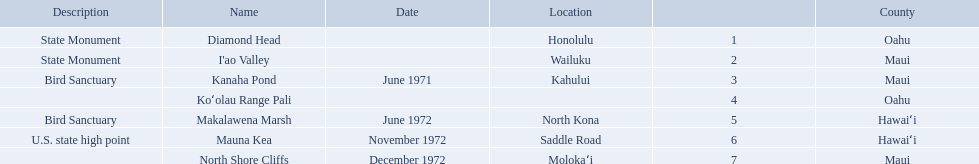What are the different landmark names? Diamond Head, I'ao Valley, Kanaha Pond, Koʻolau Range Pali, Makalawena Marsh, Mauna Kea, North Shore Cliffs. Which of these is located in the county hawai`i? Makalawena Marsh, Mauna Kea. Which of these is not mauna kea? Makalawena Marsh. What are all of the landmark names in hawaii? Diamond Head, I'ao Valley, Kanaha Pond, Koʻolau Range Pali, Makalawena Marsh, Mauna Kea, North Shore Cliffs. What are their descriptions? State Monument, State Monument, Bird Sanctuary, , Bird Sanctuary, U.S. state high point, . And which is described as a u.s. state high point? Mauna Kea. 